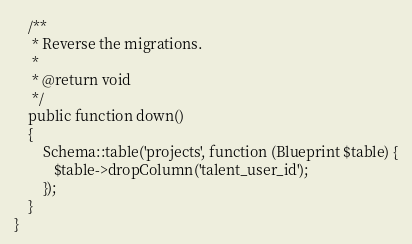<code> <loc_0><loc_0><loc_500><loc_500><_PHP_>    /**
     * Reverse the migrations.
     *
     * @return void
     */
    public function down()
    {
        Schema::table('projects', function (Blueprint $table) {
           $table->dropColumn('talent_user_id');
        });
    }
}
</code> 